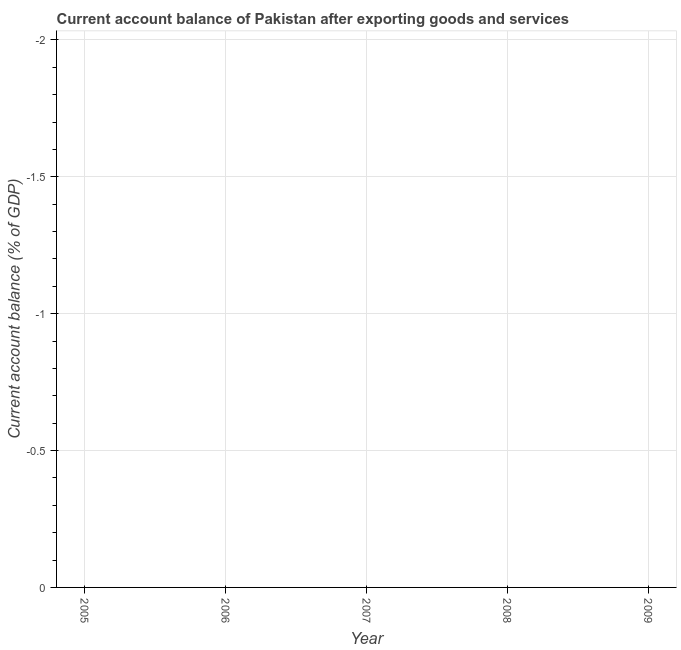What is the current account balance in 2009?
Provide a short and direct response. 0. Across all years, what is the minimum current account balance?
Provide a succinct answer. 0. In how many years, is the current account balance greater than the average current account balance taken over all years?
Your answer should be compact. 0. How many years are there in the graph?
Provide a short and direct response. 5. What is the difference between two consecutive major ticks on the Y-axis?
Give a very brief answer. 0.5. Are the values on the major ticks of Y-axis written in scientific E-notation?
Your answer should be compact. No. Does the graph contain any zero values?
Ensure brevity in your answer.  Yes. What is the title of the graph?
Ensure brevity in your answer.  Current account balance of Pakistan after exporting goods and services. What is the label or title of the X-axis?
Your answer should be very brief. Year. What is the label or title of the Y-axis?
Your response must be concise. Current account balance (% of GDP). What is the Current account balance (% of GDP) in 2005?
Offer a very short reply. 0. What is the Current account balance (% of GDP) in 2006?
Provide a short and direct response. 0. What is the Current account balance (% of GDP) in 2007?
Offer a very short reply. 0. What is the Current account balance (% of GDP) in 2009?
Make the answer very short. 0. 